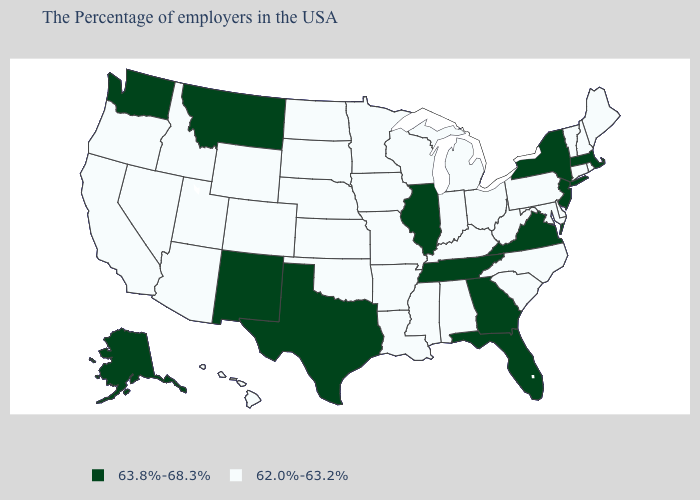Which states have the lowest value in the USA?
Short answer required. Maine, Rhode Island, New Hampshire, Vermont, Connecticut, Delaware, Maryland, Pennsylvania, North Carolina, South Carolina, West Virginia, Ohio, Michigan, Kentucky, Indiana, Alabama, Wisconsin, Mississippi, Louisiana, Missouri, Arkansas, Minnesota, Iowa, Kansas, Nebraska, Oklahoma, South Dakota, North Dakota, Wyoming, Colorado, Utah, Arizona, Idaho, Nevada, California, Oregon, Hawaii. What is the value of West Virginia?
Give a very brief answer. 62.0%-63.2%. What is the value of Nevada?
Keep it brief. 62.0%-63.2%. Name the states that have a value in the range 62.0%-63.2%?
Give a very brief answer. Maine, Rhode Island, New Hampshire, Vermont, Connecticut, Delaware, Maryland, Pennsylvania, North Carolina, South Carolina, West Virginia, Ohio, Michigan, Kentucky, Indiana, Alabama, Wisconsin, Mississippi, Louisiana, Missouri, Arkansas, Minnesota, Iowa, Kansas, Nebraska, Oklahoma, South Dakota, North Dakota, Wyoming, Colorado, Utah, Arizona, Idaho, Nevada, California, Oregon, Hawaii. Does the first symbol in the legend represent the smallest category?
Keep it brief. No. Which states have the lowest value in the USA?
Give a very brief answer. Maine, Rhode Island, New Hampshire, Vermont, Connecticut, Delaware, Maryland, Pennsylvania, North Carolina, South Carolina, West Virginia, Ohio, Michigan, Kentucky, Indiana, Alabama, Wisconsin, Mississippi, Louisiana, Missouri, Arkansas, Minnesota, Iowa, Kansas, Nebraska, Oklahoma, South Dakota, North Dakota, Wyoming, Colorado, Utah, Arizona, Idaho, Nevada, California, Oregon, Hawaii. Name the states that have a value in the range 62.0%-63.2%?
Concise answer only. Maine, Rhode Island, New Hampshire, Vermont, Connecticut, Delaware, Maryland, Pennsylvania, North Carolina, South Carolina, West Virginia, Ohio, Michigan, Kentucky, Indiana, Alabama, Wisconsin, Mississippi, Louisiana, Missouri, Arkansas, Minnesota, Iowa, Kansas, Nebraska, Oklahoma, South Dakota, North Dakota, Wyoming, Colorado, Utah, Arizona, Idaho, Nevada, California, Oregon, Hawaii. What is the lowest value in the MidWest?
Keep it brief. 62.0%-63.2%. What is the value of New Jersey?
Quick response, please. 63.8%-68.3%. Does the first symbol in the legend represent the smallest category?
Quick response, please. No. Name the states that have a value in the range 63.8%-68.3%?
Answer briefly. Massachusetts, New York, New Jersey, Virginia, Florida, Georgia, Tennessee, Illinois, Texas, New Mexico, Montana, Washington, Alaska. What is the value of South Carolina?
Concise answer only. 62.0%-63.2%. What is the value of New Mexico?
Write a very short answer. 63.8%-68.3%. Which states have the highest value in the USA?
Quick response, please. Massachusetts, New York, New Jersey, Virginia, Florida, Georgia, Tennessee, Illinois, Texas, New Mexico, Montana, Washington, Alaska. 